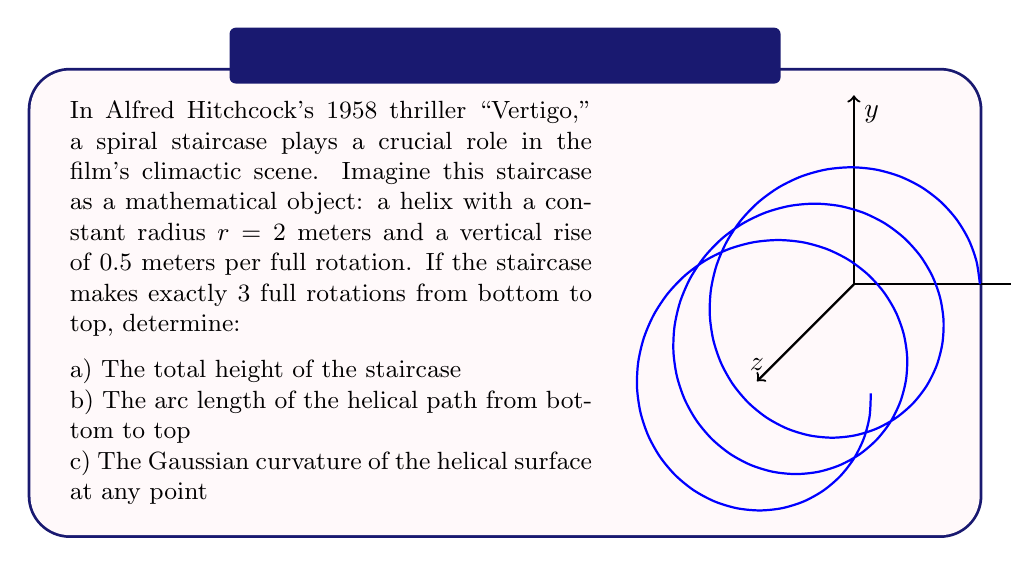Give your solution to this math problem. Let's approach this problem step-by-step:

a) To find the total height of the staircase:
   - Each full rotation rises 0.5 meters
   - There are 3 full rotations
   - Total height = $3 \times 0.5 = 1.5$ meters

b) To calculate the arc length of the helical path:
   - The parametric equations for a helix are:
     $x = r \cos(t)$, $y = r \sin(t)$, $z = ct$
     where $c$ is the vertical rise per radian.
   - In this case, $r = 2$ and $c = \frac{0.5}{2\pi}$
   - The arc length is given by:
     $$L = \int_0^{6\pi} \sqrt{(\frac{dx}{dt})^2 + (\frac{dy}{dt})^2 + (\frac{dz}{dt})^2} dt$$
   - Substituting and simplifying:
     $$L = \int_0^{6\pi} \sqrt{4\sin^2(t) + 4\cos^2(t) + (\frac{0.5}{2\pi})^2} dt$$
     $$L = \int_0^{6\pi} \sqrt{4 + (\frac{0.5}{2\pi})^2} dt$$
     $$L = 6\pi \sqrt{4 + (\frac{0.5}{2\pi})^2} \approx 37.70 \text{ meters}$$

c) To find the Gaussian curvature:
   - For a helical surface, the Gaussian curvature $K$ is constant and given by:
     $$K = \frac{-c^2r^2}{(r^2 + c^2)^2}$$
   - Substituting $r = 2$ and $c = \frac{0.5}{2\pi}$:
     $$K = \frac{-(\frac{0.5}{2\pi})^2 \cdot 2^2}{(2^2 + (\frac{0.5}{2\pi})^2)^2} \approx -0.00158 \text{ m}^{-2}$$

The negative Gaussian curvature indicates that the surface is hyperbolic at every point.
Answer: a) 1.5 m
b) 37.70 m
c) -0.00158 m^(-2) 